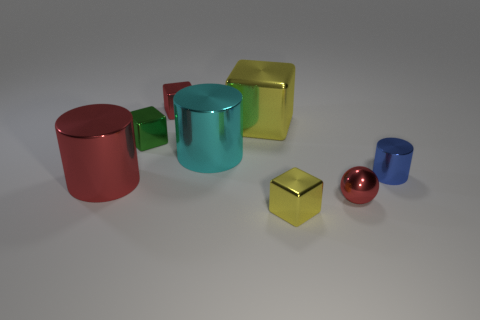Subtract 1 cubes. How many cubes are left? 3 Subtract all blue blocks. Subtract all green balls. How many blocks are left? 4 Add 2 big gray metal objects. How many objects exist? 10 Subtract all cylinders. How many objects are left? 5 Add 4 small shiny cylinders. How many small shiny cylinders are left? 5 Add 1 small purple spheres. How many small purple spheres exist? 1 Subtract 0 yellow balls. How many objects are left? 8 Subtract all big cylinders. Subtract all yellow objects. How many objects are left? 4 